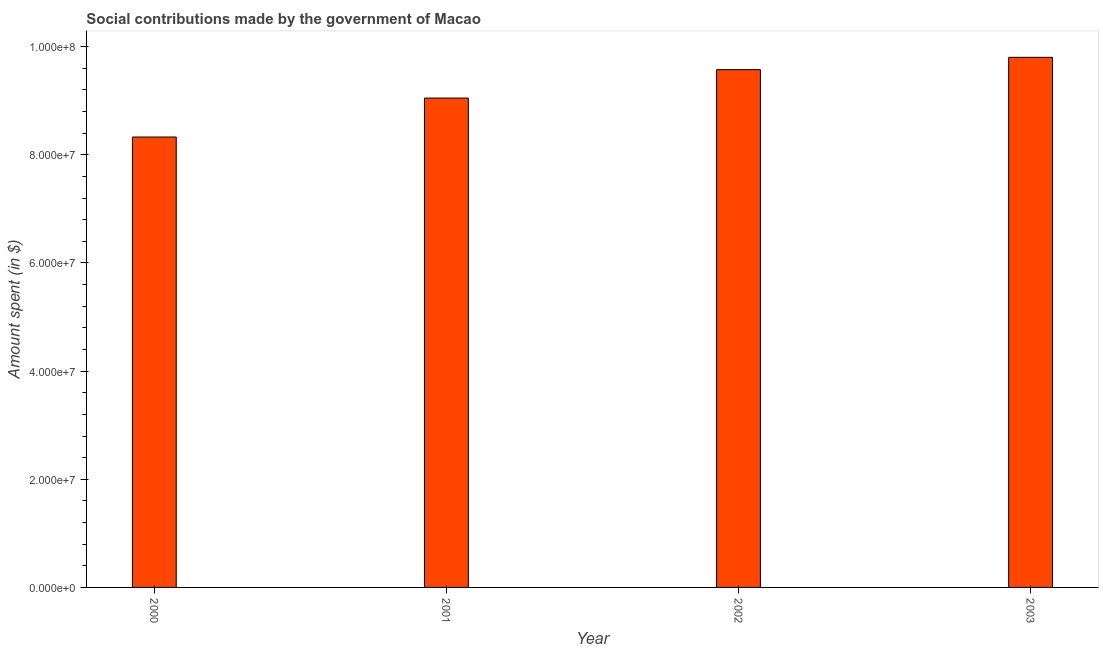Does the graph contain any zero values?
Provide a succinct answer. No. Does the graph contain grids?
Offer a terse response. No. What is the title of the graph?
Your answer should be compact. Social contributions made by the government of Macao. What is the label or title of the X-axis?
Offer a very short reply. Year. What is the label or title of the Y-axis?
Make the answer very short. Amount spent (in $). What is the amount spent in making social contributions in 2000?
Provide a short and direct response. 8.33e+07. Across all years, what is the maximum amount spent in making social contributions?
Provide a short and direct response. 9.80e+07. Across all years, what is the minimum amount spent in making social contributions?
Keep it short and to the point. 8.33e+07. In which year was the amount spent in making social contributions maximum?
Provide a short and direct response. 2003. What is the sum of the amount spent in making social contributions?
Your answer should be very brief. 3.68e+08. What is the difference between the amount spent in making social contributions in 2001 and 2003?
Offer a terse response. -7.53e+06. What is the average amount spent in making social contributions per year?
Ensure brevity in your answer.  9.19e+07. What is the median amount spent in making social contributions?
Offer a very short reply. 9.31e+07. What is the ratio of the amount spent in making social contributions in 2000 to that in 2002?
Your answer should be compact. 0.87. What is the difference between the highest and the second highest amount spent in making social contributions?
Your answer should be compact. 2.28e+06. What is the difference between the highest and the lowest amount spent in making social contributions?
Your answer should be very brief. 1.47e+07. What is the Amount spent (in $) in 2000?
Offer a terse response. 8.33e+07. What is the Amount spent (in $) in 2001?
Your answer should be very brief. 9.05e+07. What is the Amount spent (in $) in 2002?
Offer a terse response. 9.58e+07. What is the Amount spent (in $) in 2003?
Ensure brevity in your answer.  9.80e+07. What is the difference between the Amount spent (in $) in 2000 and 2001?
Offer a terse response. -7.20e+06. What is the difference between the Amount spent (in $) in 2000 and 2002?
Offer a very short reply. -1.25e+07. What is the difference between the Amount spent (in $) in 2000 and 2003?
Provide a short and direct response. -1.47e+07. What is the difference between the Amount spent (in $) in 2001 and 2002?
Give a very brief answer. -5.26e+06. What is the difference between the Amount spent (in $) in 2001 and 2003?
Your answer should be very brief. -7.53e+06. What is the difference between the Amount spent (in $) in 2002 and 2003?
Keep it short and to the point. -2.28e+06. What is the ratio of the Amount spent (in $) in 2000 to that in 2001?
Provide a short and direct response. 0.92. What is the ratio of the Amount spent (in $) in 2000 to that in 2002?
Make the answer very short. 0.87. What is the ratio of the Amount spent (in $) in 2000 to that in 2003?
Your answer should be compact. 0.85. What is the ratio of the Amount spent (in $) in 2001 to that in 2002?
Give a very brief answer. 0.94. What is the ratio of the Amount spent (in $) in 2001 to that in 2003?
Keep it short and to the point. 0.92. What is the ratio of the Amount spent (in $) in 2002 to that in 2003?
Give a very brief answer. 0.98. 